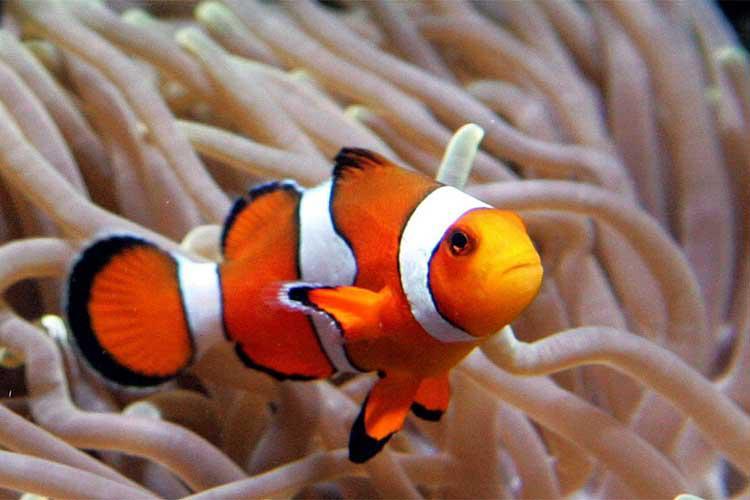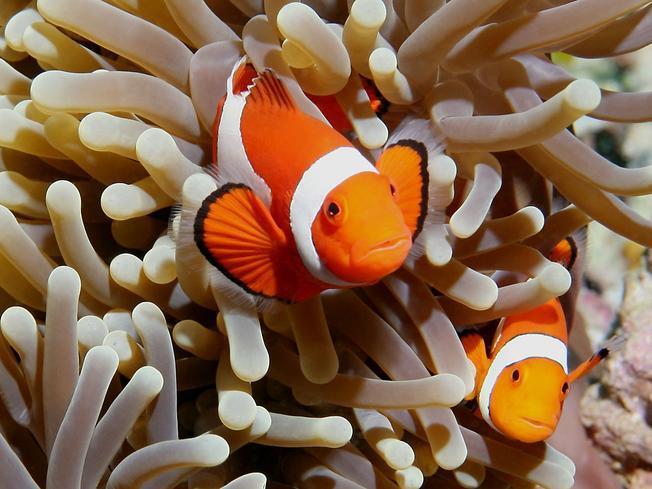The first image is the image on the left, the second image is the image on the right. For the images displayed, is the sentence "There is only one clownfish on the right image" factually correct? Answer yes or no. No. The first image is the image on the left, the second image is the image on the right. Given the left and right images, does the statement "There are three fish" hold true? Answer yes or no. Yes. 